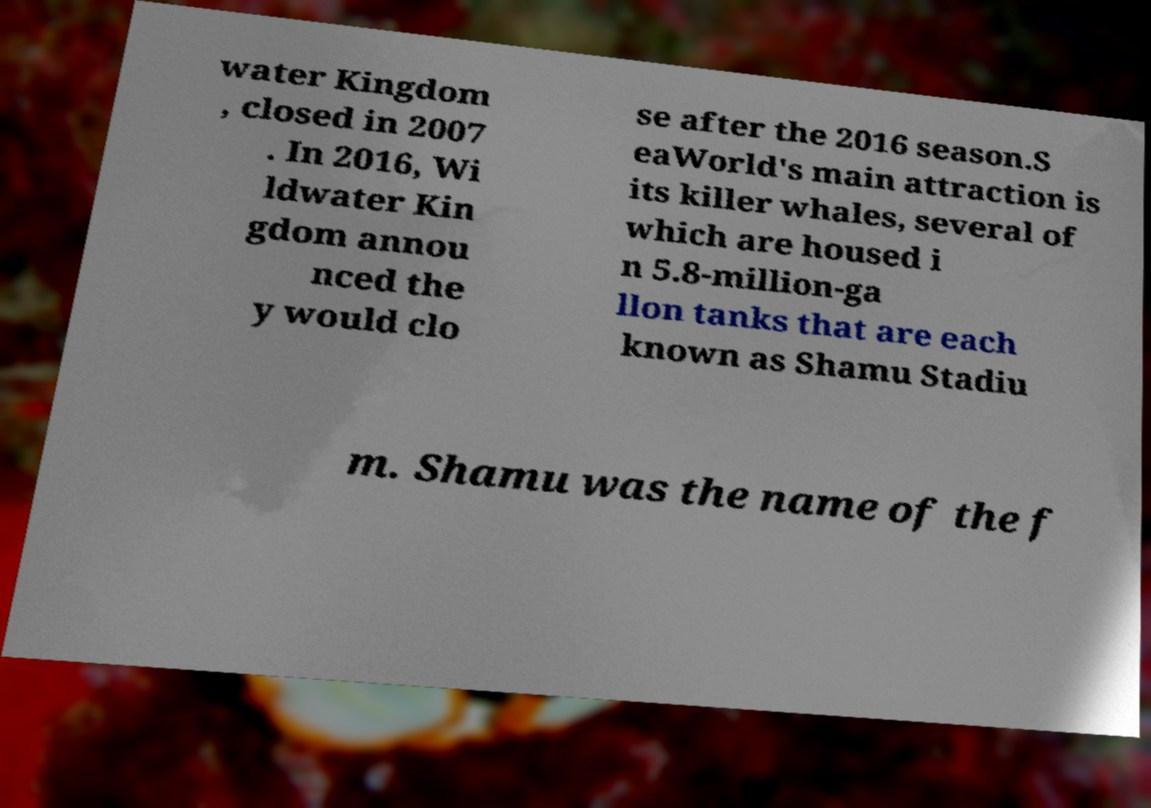Can you accurately transcribe the text from the provided image for me? water Kingdom , closed in 2007 . In 2016, Wi ldwater Kin gdom annou nced the y would clo se after the 2016 season.S eaWorld's main attraction is its killer whales, several of which are housed i n 5.8-million-ga llon tanks that are each known as Shamu Stadiu m. Shamu was the name of the f 